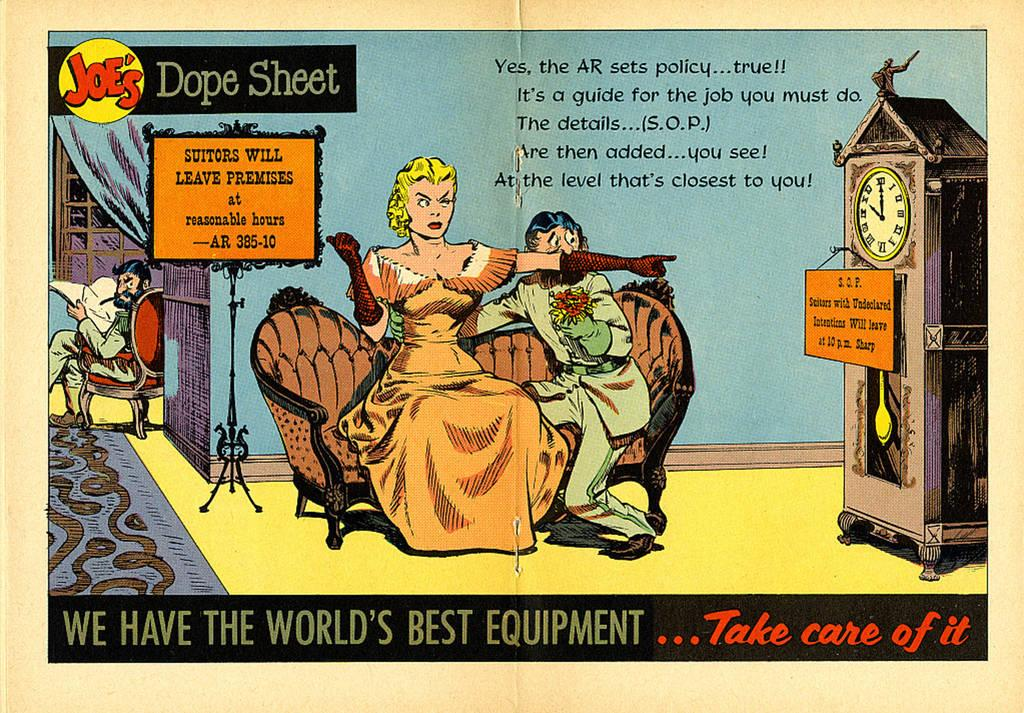<image>
Summarize the visual content of the image. Joe's Dope Sheet offers a satire cartoon about a Victorian woman. 